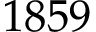Convert formula to latex. <formula><loc_0><loc_0><loc_500><loc_500>1 8 5 9</formula> 